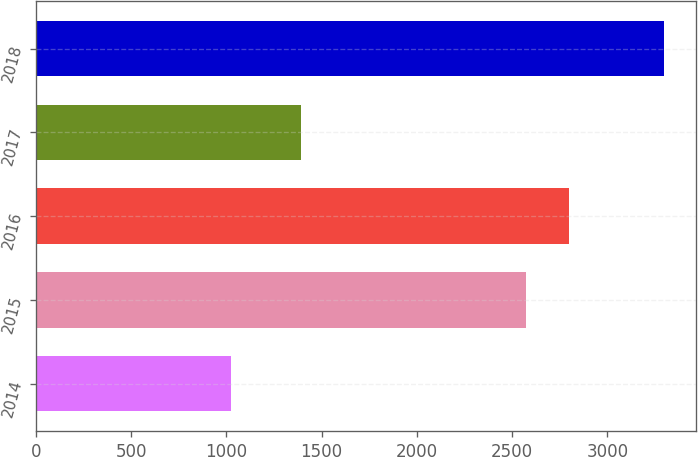Convert chart. <chart><loc_0><loc_0><loc_500><loc_500><bar_chart><fcel>2014<fcel>2015<fcel>2016<fcel>2017<fcel>2018<nl><fcel>1024<fcel>2573<fcel>2800.4<fcel>1394<fcel>3298<nl></chart> 